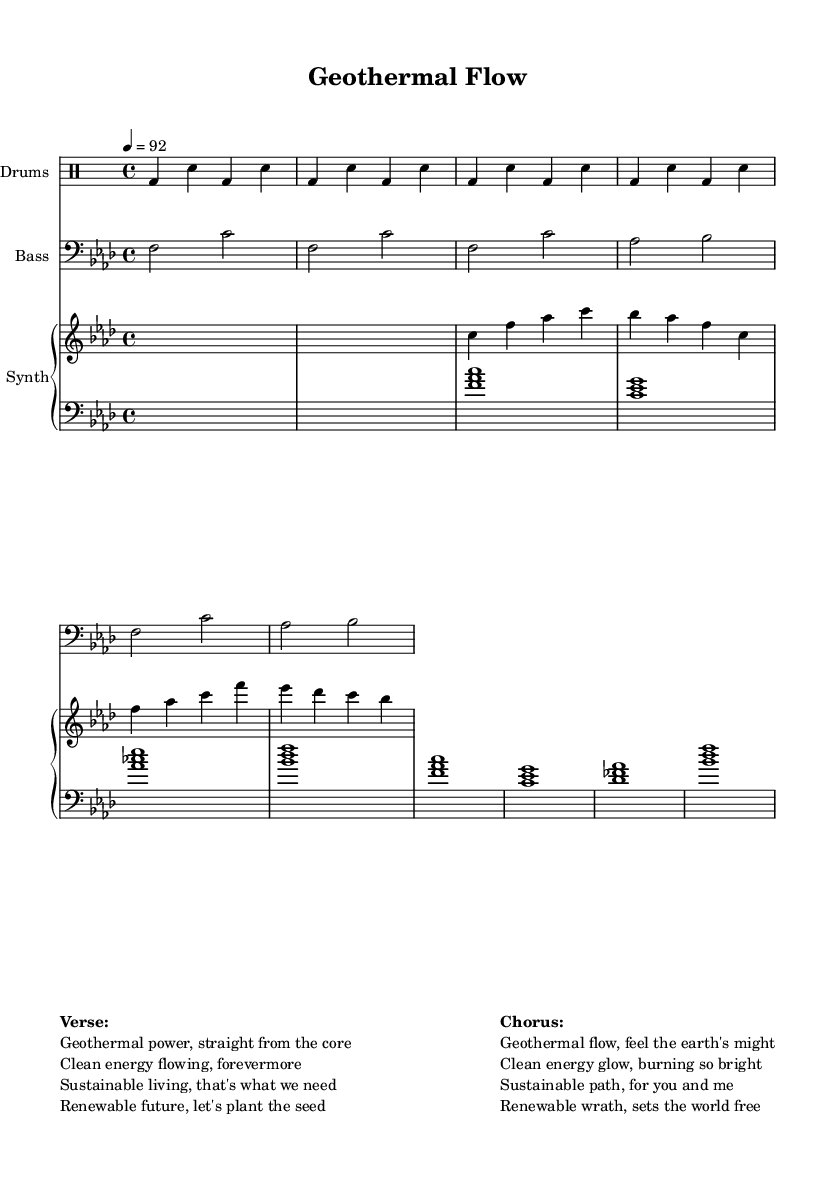What is the key signature of this music? The key signature is F minor, which includes four flats. This can be determined from the beginning of the sheet music where the flats are indicated.
Answer: F minor What is the time signature of this music? The time signature is 4/4, which means there are four beats in each measure and the quarter note gets one beat. This is visible next to the treble clef at the start of the score.
Answer: 4/4 What is the tempo marking of the piece? The tempo marking is 92, indicating that the piece should be played at a speed of 92 beats per minute. This is specified in the score near the top of the sheet music.
Answer: 92 What are the first two lines of the verse? The first two lines in the verse are "Geothermal power, straight from the core" and "Clean energy flowing, forevermore." These lyrics can be found in the markup section at the bottom of the score.
Answer: Geothermal power, straight from the core; Clean energy flowing, forevermore How many times does the drum beat repeat in the first section? The drum beat repeats four times as indicated by the \repeat command in the drum part, which specifies "unfold 4." This shows that the pattern is played four times sequentially.
Answer: 4 What elements in this hip-hop track focus on themes of sustainability? The lyrics emphasize geothermal energy, sustainable living, and renewable resources, which are central themes in promoting environmental stewardship and green energy. This can be observed in both the verse and chorus as they discuss the importance of clean energy and its impact.
Answer: Geothermal energy, sustainable living, renewable resources What type of musical components are used to represent the synth pad? The synth pad is represented using chord mode, indicated in the score as s1 for rest, and then showing the specific chord progressions listed. It typically accompanies the lead synth and bass line.
Answer: Chord mode 